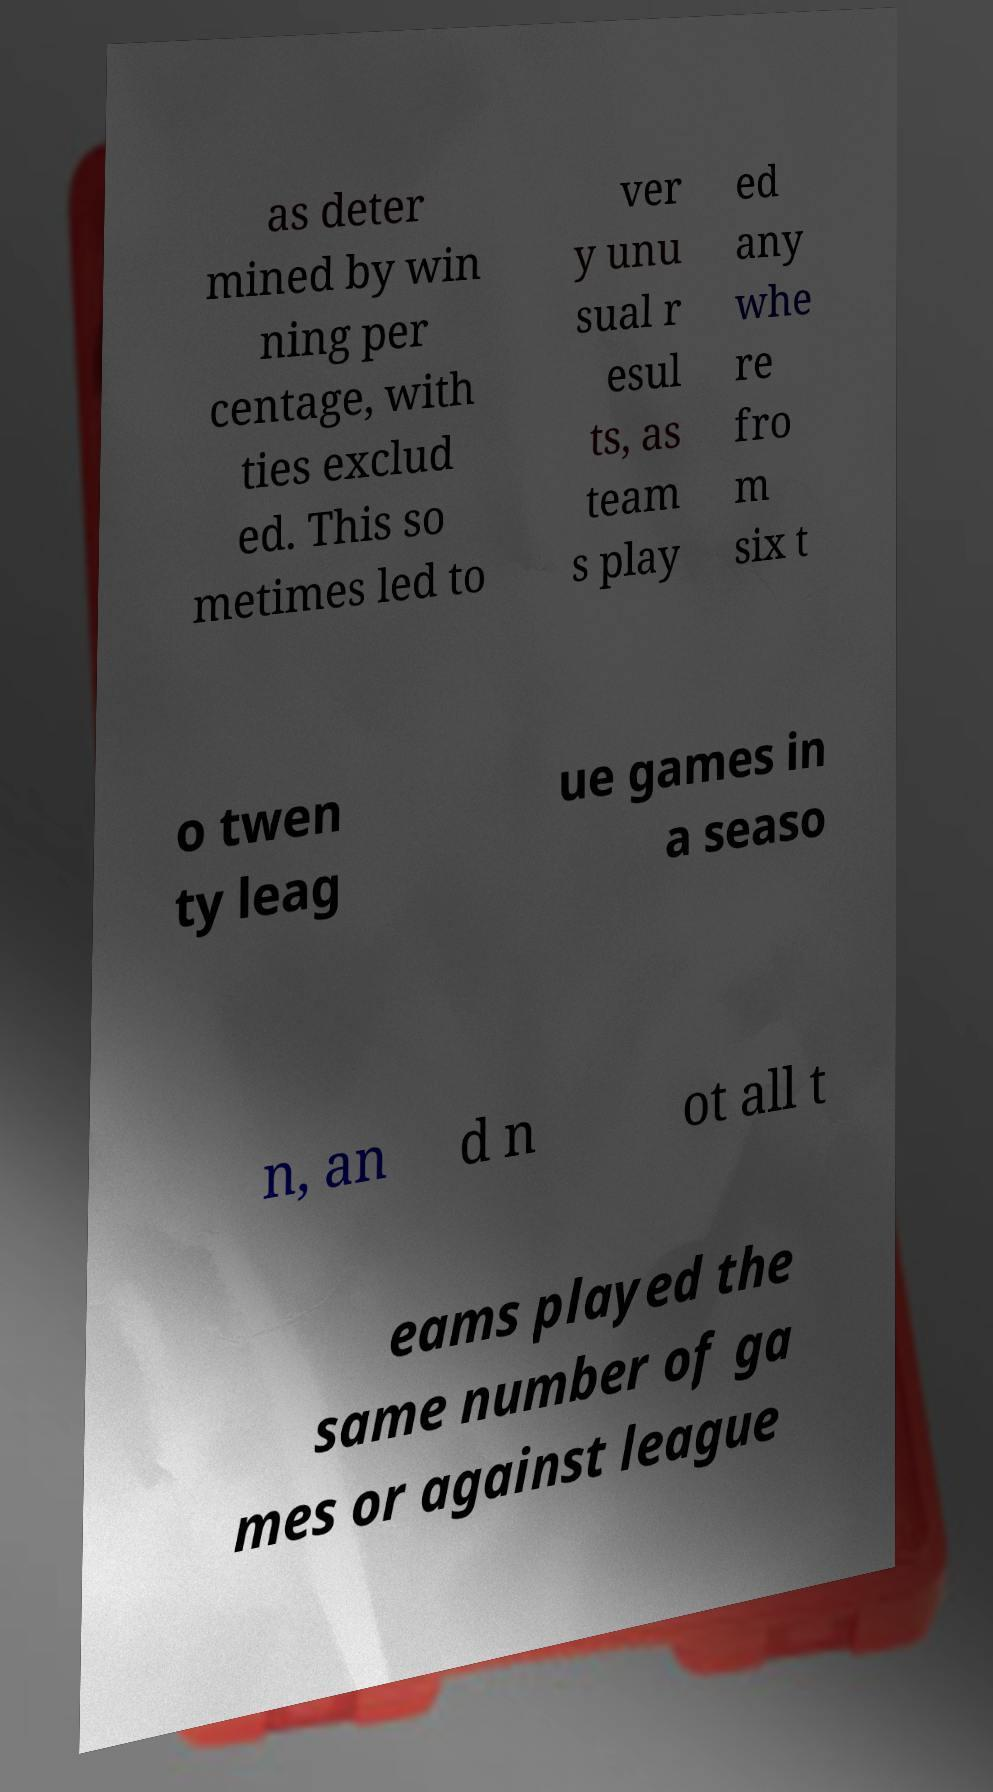There's text embedded in this image that I need extracted. Can you transcribe it verbatim? as deter mined by win ning per centage, with ties exclud ed. This so metimes led to ver y unu sual r esul ts, as team s play ed any whe re fro m six t o twen ty leag ue games in a seaso n, an d n ot all t eams played the same number of ga mes or against league 